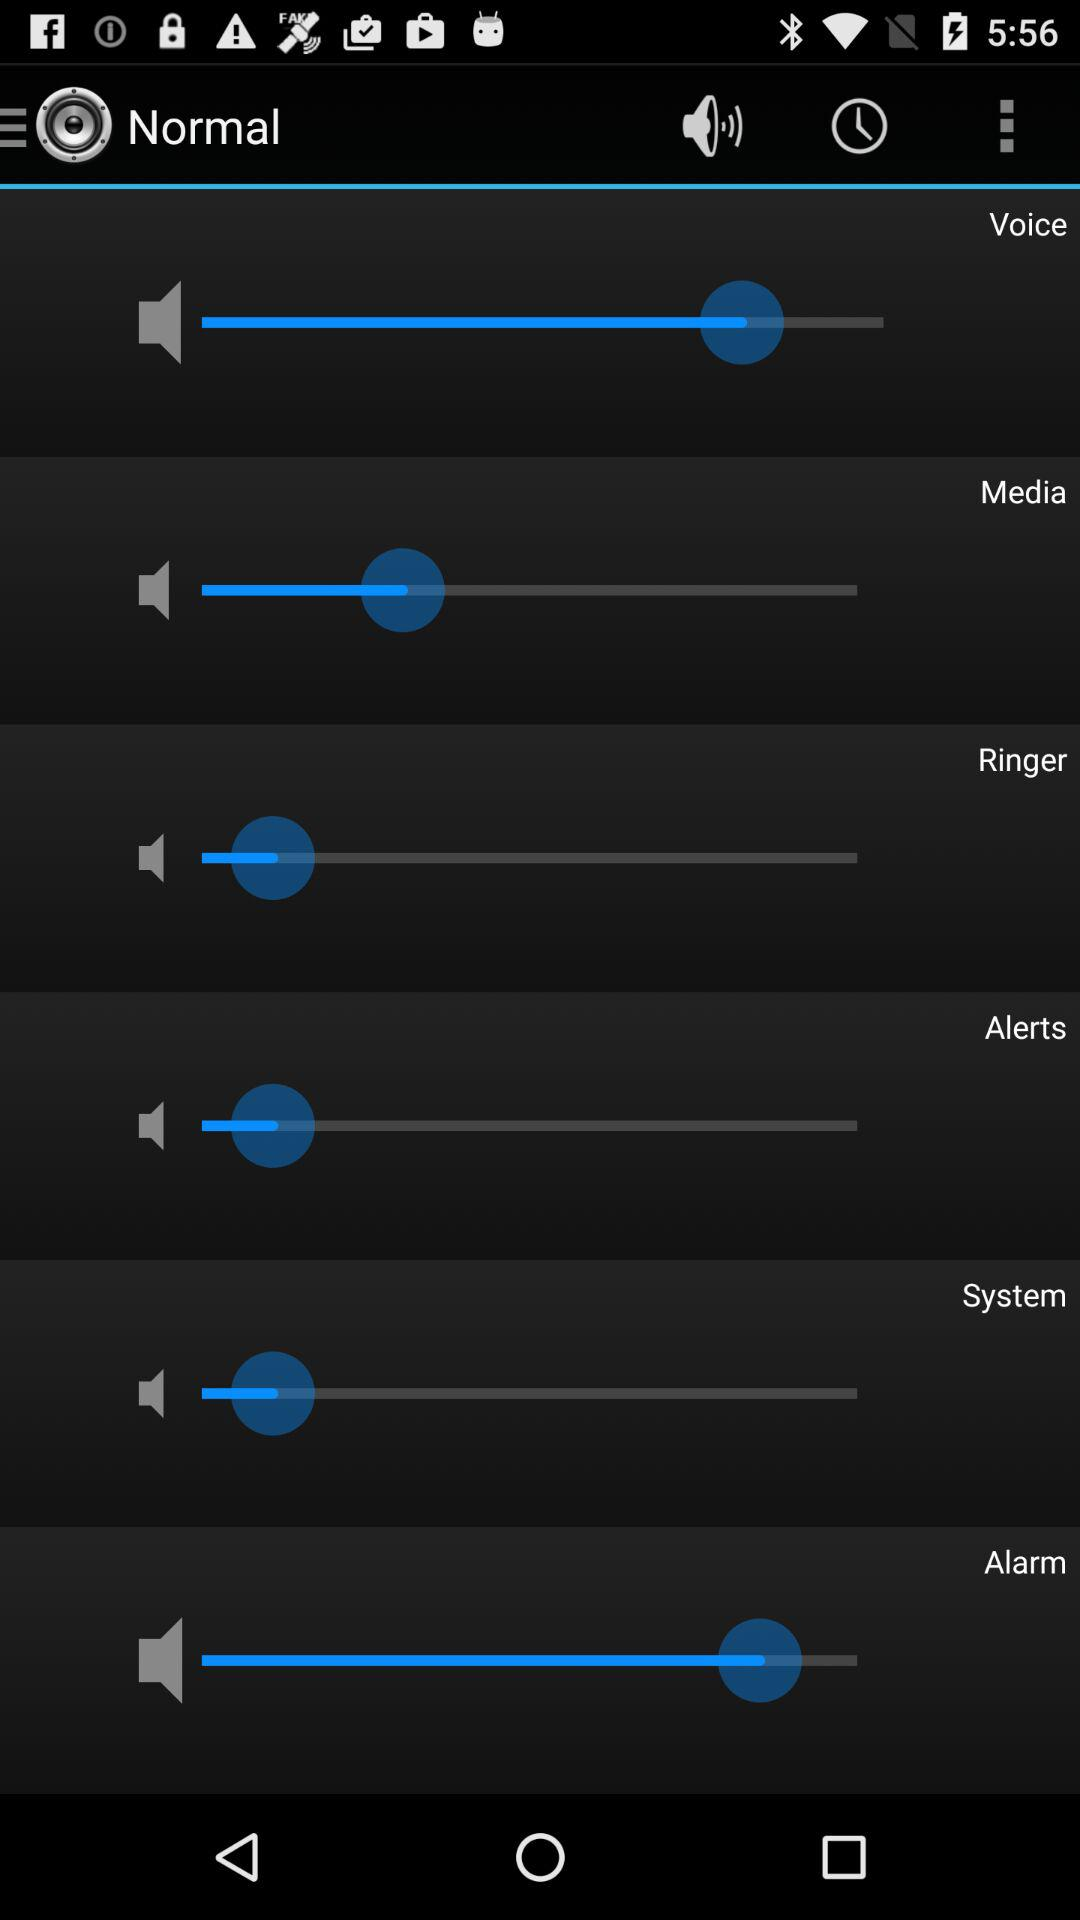How many volume sliders are there on this screen?
Answer the question using a single word or phrase. 6 